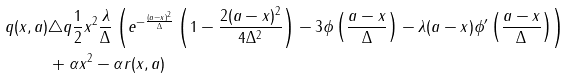<formula> <loc_0><loc_0><loc_500><loc_500>q ( x , a ) & \triangle q \frac { 1 } { 2 } x ^ { 2 } \frac { \lambda } { \Delta } \left ( e ^ { - \frac { ( a - x ) ^ { 2 } } { \Delta } } \left ( 1 - \frac { 2 ( a - x ) ^ { 2 } } { 4 \Delta ^ { 2 } } \right ) - 3 \phi \left ( \frac { a - x } { \Delta } \right ) - \lambda ( a - x ) \phi ^ { \prime } \left ( \frac { a - x } { \Delta } \right ) \right ) \\ & + \alpha x ^ { 2 } - \alpha r ( x , a )</formula> 